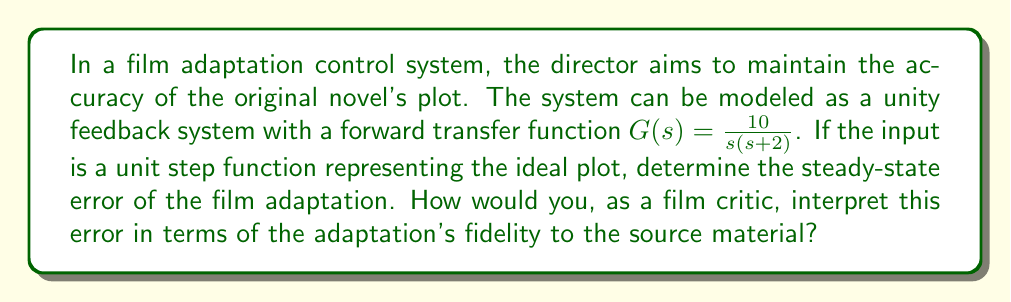Provide a solution to this math problem. To solve this problem, we'll follow these steps:

1) First, we need to determine the system type. The forward transfer function is:

   $$G(s) = \frac{10}{s(s+2)}$$

   This has one pole at $s=0$, so it's a Type 1 system.

2) For a Type 1 system with a step input, the steady-state error is given by:

   $$e_{ss} = \frac{1}{1 + K_v}$$

   where $K_v$ is the velocity error constant.

3) To find $K_v$, we use the formula:

   $$K_v = \lim_{s \to 0} sG(s)$$

4) Substituting our transfer function:

   $$K_v = \lim_{s \to 0} s\frac{10}{s(s+2)} = \lim_{s \to 0} \frac{10}{s+2} = 5$$

5) Now we can calculate the steady-state error:

   $$e_{ss} = \frac{1}{1 + K_v} = \frac{1}{1 + 5} = \frac{1}{6} \approx 0.1667$$

6) This means the steady-state error is approximately 16.67%.

Interpretation for a film critic: This steady-state error suggests that the film adaptation maintains about 83.33% accuracy to the original plot in the long run. While it captures a significant portion of the source material, there's still a noticeable deviation from the original story. This could represent changes in plot details, character development, or thematic elements that differ from the novel.
Answer: The steady-state error is $\frac{1}{6}$ or approximately 16.67%. This indicates that the film adaptation maintains about 83.33% fidelity to the original novel's plot in the steady state. 